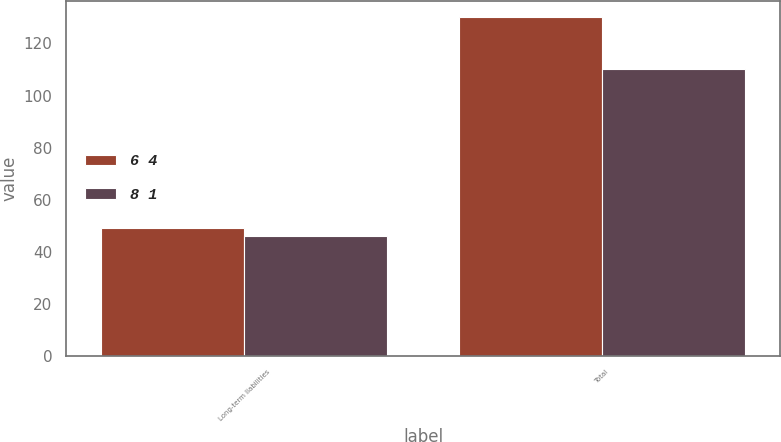<chart> <loc_0><loc_0><loc_500><loc_500><stacked_bar_chart><ecel><fcel>Long-term liabilities<fcel>Total<nl><fcel>6 4<fcel>49<fcel>130<nl><fcel>8 1<fcel>46<fcel>110<nl></chart> 